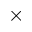Convert formula to latex. <formula><loc_0><loc_0><loc_500><loc_500>\times</formula> 